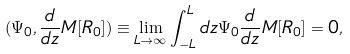<formula> <loc_0><loc_0><loc_500><loc_500>( \Psi _ { 0 } , \frac { d } { d z } M [ R _ { 0 } ] ) \equiv \lim _ { L \to \infty } \int _ { - L } ^ { L } d z \Psi _ { 0 } \frac { d } { d z } M [ R _ { 0 } ] = 0 ,</formula> 